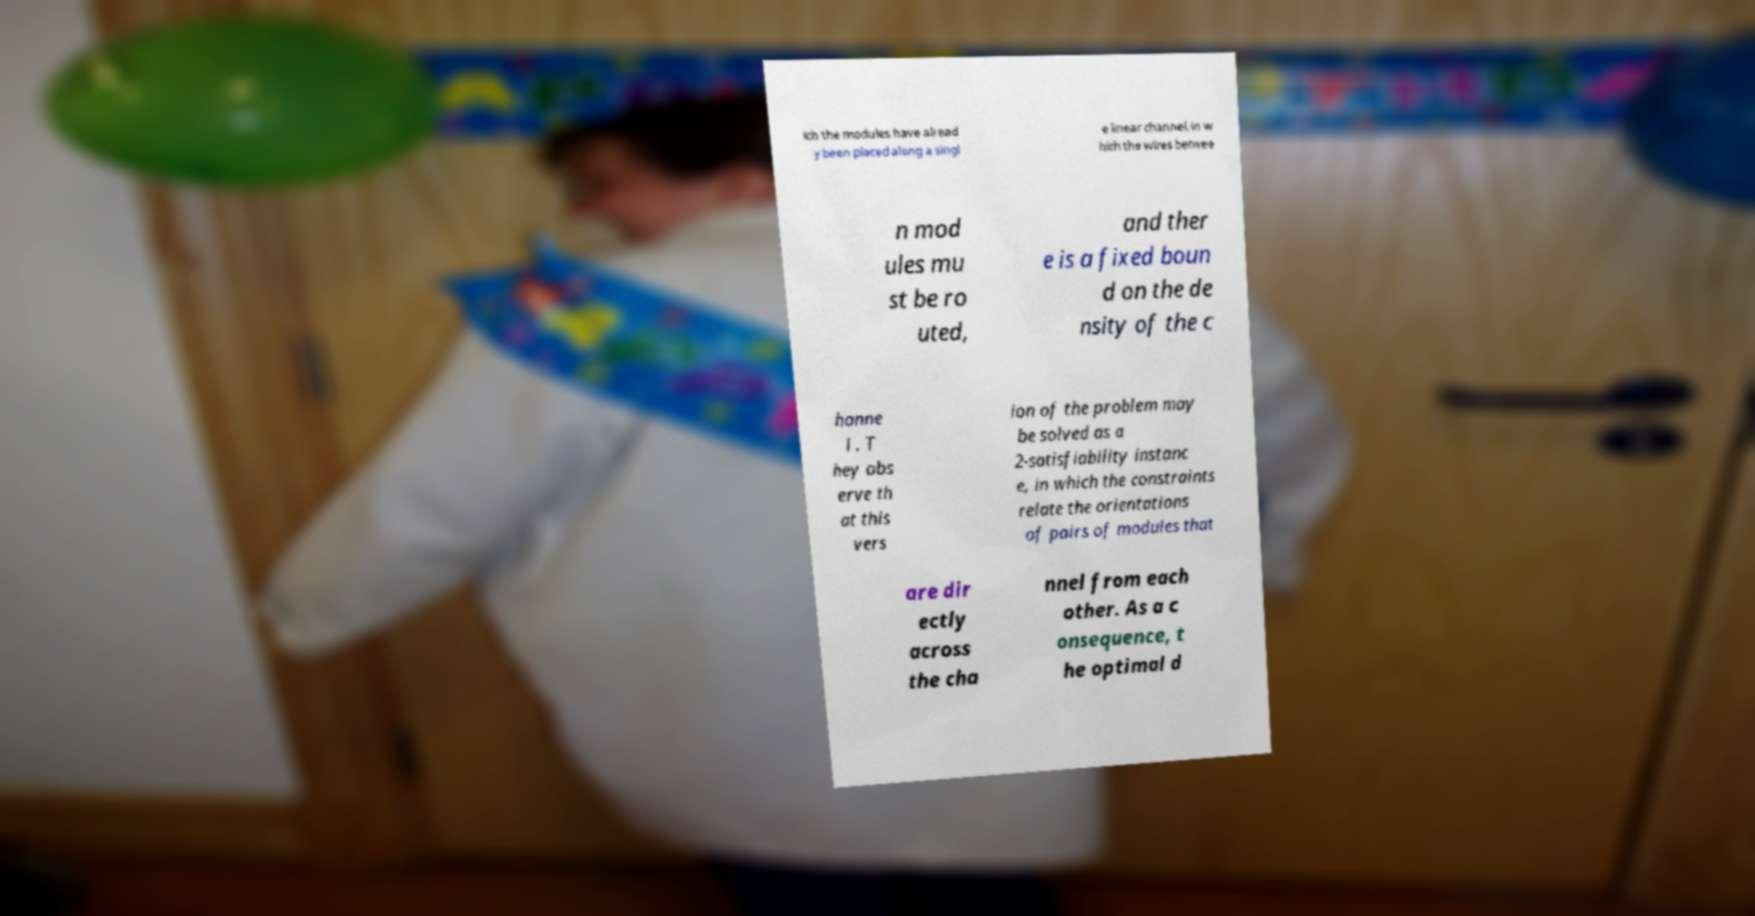Please identify and transcribe the text found in this image. ich the modules have alread y been placed along a singl e linear channel, in w hich the wires betwee n mod ules mu st be ro uted, and ther e is a fixed boun d on the de nsity of the c hanne l . T hey obs erve th at this vers ion of the problem may be solved as a 2-satisfiability instanc e, in which the constraints relate the orientations of pairs of modules that are dir ectly across the cha nnel from each other. As a c onsequence, t he optimal d 